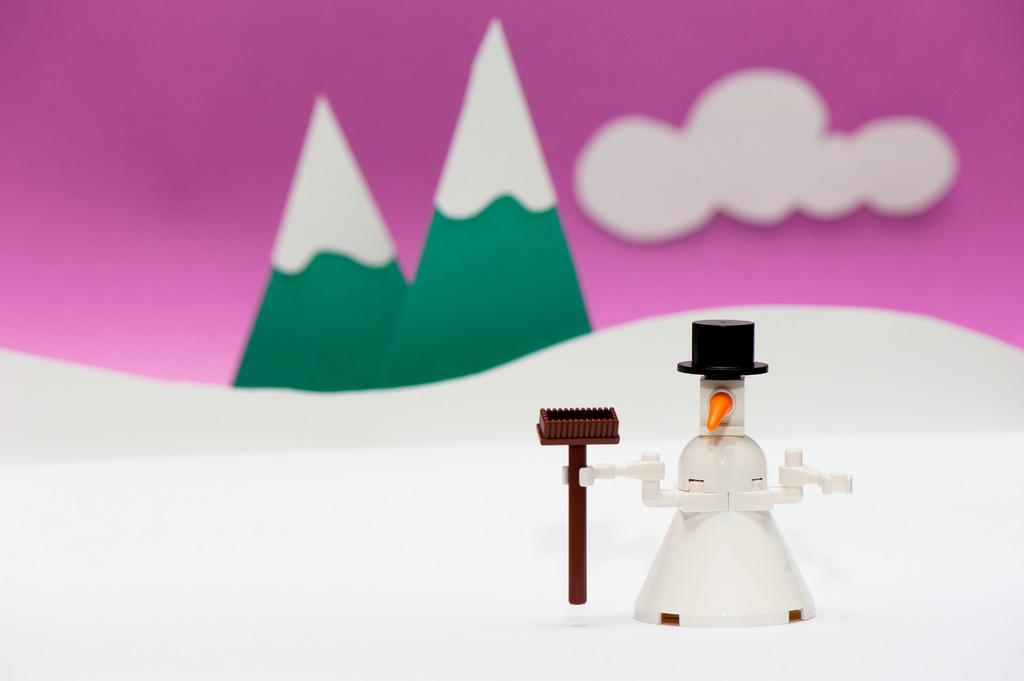What type of toy can be seen in the image? There is a white toy in the image. What other toys are present in the image? There are toy trees in the image. What can be seen in the sky in the image? There is a cloud visible in the image. What type of car is parked next to the white toy in the image? There is no car present in the image; it only features a white toy and toy trees. 